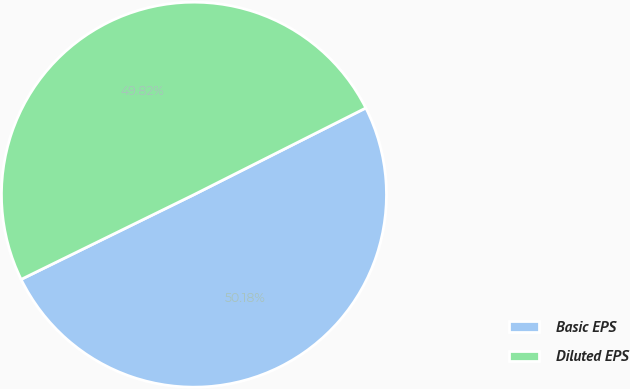Convert chart to OTSL. <chart><loc_0><loc_0><loc_500><loc_500><pie_chart><fcel>Basic EPS<fcel>Diluted EPS<nl><fcel>50.18%<fcel>49.82%<nl></chart> 